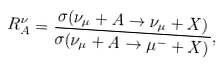Convert formula to latex. <formula><loc_0><loc_0><loc_500><loc_500>R ^ { \nu } _ { A } = \frac { \sigma ( \nu _ { \mu } + A \to \nu _ { \mu } + X ) } { \sigma ( \nu _ { \mu } + A \to \mu ^ { - } + X ) } ,</formula> 